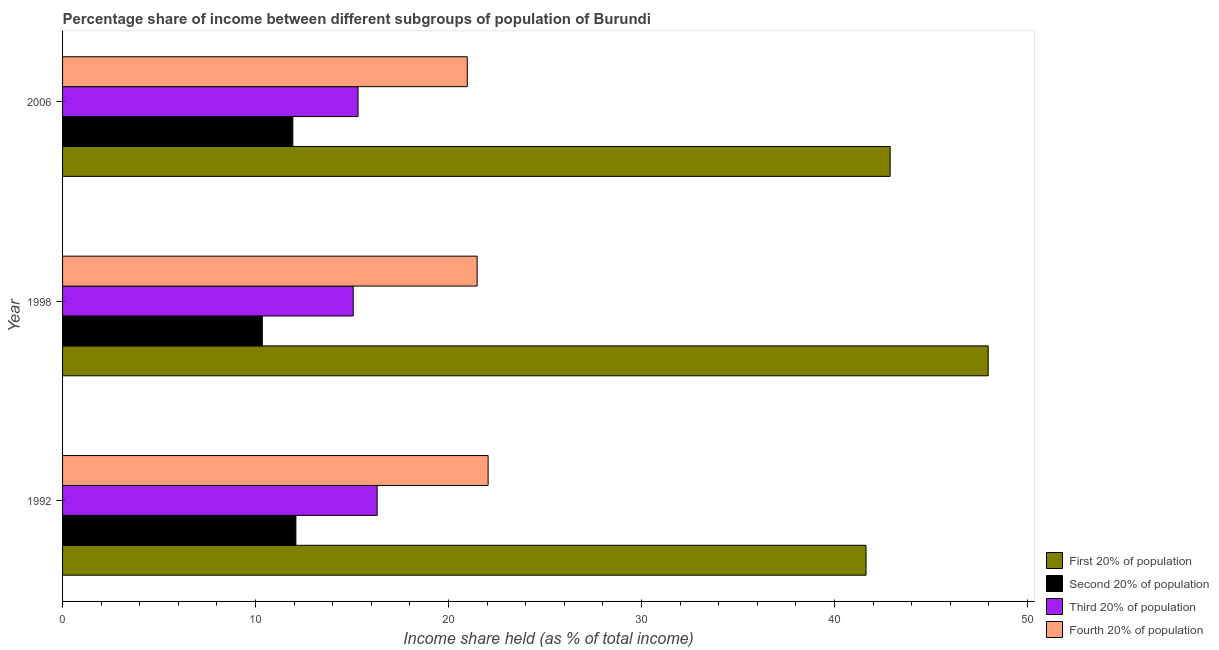How many bars are there on the 3rd tick from the top?
Your answer should be compact. 4. What is the label of the 1st group of bars from the top?
Your answer should be compact. 2006. In how many cases, is the number of bars for a given year not equal to the number of legend labels?
Your response must be concise. 0. What is the share of the income held by fourth 20% of the population in 2006?
Give a very brief answer. 20.97. Across all years, what is the maximum share of the income held by fourth 20% of the population?
Provide a succinct answer. 22.05. Across all years, what is the minimum share of the income held by third 20% of the population?
Your answer should be compact. 15.06. What is the total share of the income held by second 20% of the population in the graph?
Give a very brief answer. 34.37. What is the difference between the share of the income held by first 20% of the population in 1998 and that in 2006?
Make the answer very short. 5.08. What is the difference between the share of the income held by first 20% of the population in 1998 and the share of the income held by second 20% of the population in 2006?
Keep it short and to the point. 36.03. What is the average share of the income held by third 20% of the population per year?
Give a very brief answer. 15.56. In the year 2006, what is the difference between the share of the income held by second 20% of the population and share of the income held by third 20% of the population?
Offer a terse response. -3.38. In how many years, is the share of the income held by third 20% of the population greater than 30 %?
Make the answer very short. 0. What is the ratio of the share of the income held by first 20% of the population in 1998 to that in 2006?
Keep it short and to the point. 1.12. Is the share of the income held by third 20% of the population in 1998 less than that in 2006?
Your answer should be compact. Yes. What is the difference between the highest and the second highest share of the income held by second 20% of the population?
Provide a succinct answer. 0.16. What is the difference between the highest and the lowest share of the income held by fourth 20% of the population?
Make the answer very short. 1.08. In how many years, is the share of the income held by fourth 20% of the population greater than the average share of the income held by fourth 20% of the population taken over all years?
Offer a very short reply. 1. Is the sum of the share of the income held by third 20% of the population in 1992 and 1998 greater than the maximum share of the income held by second 20% of the population across all years?
Offer a terse response. Yes. What does the 3rd bar from the top in 1992 represents?
Your answer should be very brief. Second 20% of population. What does the 3rd bar from the bottom in 1998 represents?
Offer a terse response. Third 20% of population. Is it the case that in every year, the sum of the share of the income held by first 20% of the population and share of the income held by second 20% of the population is greater than the share of the income held by third 20% of the population?
Provide a succinct answer. Yes. How many bars are there?
Provide a succinct answer. 12. How many years are there in the graph?
Give a very brief answer. 3. Are the values on the major ticks of X-axis written in scientific E-notation?
Provide a succinct answer. No. How many legend labels are there?
Offer a terse response. 4. What is the title of the graph?
Ensure brevity in your answer.  Percentage share of income between different subgroups of population of Burundi. Does "UNRWA" appear as one of the legend labels in the graph?
Offer a very short reply. No. What is the label or title of the X-axis?
Give a very brief answer. Income share held (as % of total income). What is the label or title of the Y-axis?
Offer a terse response. Year. What is the Income share held (as % of total income) of First 20% of population in 1992?
Your answer should be compact. 41.63. What is the Income share held (as % of total income) of Second 20% of population in 1992?
Your answer should be very brief. 12.09. What is the Income share held (as % of total income) in Third 20% of population in 1992?
Provide a succinct answer. 16.3. What is the Income share held (as % of total income) of Fourth 20% of population in 1992?
Your response must be concise. 22.05. What is the Income share held (as % of total income) in First 20% of population in 1998?
Offer a very short reply. 47.96. What is the Income share held (as % of total income) in Second 20% of population in 1998?
Give a very brief answer. 10.35. What is the Income share held (as % of total income) of Third 20% of population in 1998?
Give a very brief answer. 15.06. What is the Income share held (as % of total income) of Fourth 20% of population in 1998?
Offer a terse response. 21.48. What is the Income share held (as % of total income) of First 20% of population in 2006?
Your answer should be very brief. 42.88. What is the Income share held (as % of total income) in Second 20% of population in 2006?
Your answer should be very brief. 11.93. What is the Income share held (as % of total income) of Third 20% of population in 2006?
Your response must be concise. 15.31. What is the Income share held (as % of total income) in Fourth 20% of population in 2006?
Keep it short and to the point. 20.97. Across all years, what is the maximum Income share held (as % of total income) of First 20% of population?
Offer a very short reply. 47.96. Across all years, what is the maximum Income share held (as % of total income) in Second 20% of population?
Keep it short and to the point. 12.09. Across all years, what is the maximum Income share held (as % of total income) in Fourth 20% of population?
Make the answer very short. 22.05. Across all years, what is the minimum Income share held (as % of total income) in First 20% of population?
Give a very brief answer. 41.63. Across all years, what is the minimum Income share held (as % of total income) in Second 20% of population?
Give a very brief answer. 10.35. Across all years, what is the minimum Income share held (as % of total income) of Third 20% of population?
Keep it short and to the point. 15.06. Across all years, what is the minimum Income share held (as % of total income) in Fourth 20% of population?
Provide a succinct answer. 20.97. What is the total Income share held (as % of total income) in First 20% of population in the graph?
Your answer should be compact. 132.47. What is the total Income share held (as % of total income) in Second 20% of population in the graph?
Your response must be concise. 34.37. What is the total Income share held (as % of total income) in Third 20% of population in the graph?
Ensure brevity in your answer.  46.67. What is the total Income share held (as % of total income) in Fourth 20% of population in the graph?
Keep it short and to the point. 64.5. What is the difference between the Income share held (as % of total income) in First 20% of population in 1992 and that in 1998?
Offer a terse response. -6.33. What is the difference between the Income share held (as % of total income) of Second 20% of population in 1992 and that in 1998?
Ensure brevity in your answer.  1.74. What is the difference between the Income share held (as % of total income) in Third 20% of population in 1992 and that in 1998?
Your response must be concise. 1.24. What is the difference between the Income share held (as % of total income) of Fourth 20% of population in 1992 and that in 1998?
Keep it short and to the point. 0.57. What is the difference between the Income share held (as % of total income) of First 20% of population in 1992 and that in 2006?
Offer a terse response. -1.25. What is the difference between the Income share held (as % of total income) in Second 20% of population in 1992 and that in 2006?
Offer a terse response. 0.16. What is the difference between the Income share held (as % of total income) in Fourth 20% of population in 1992 and that in 2006?
Give a very brief answer. 1.08. What is the difference between the Income share held (as % of total income) of First 20% of population in 1998 and that in 2006?
Your answer should be very brief. 5.08. What is the difference between the Income share held (as % of total income) in Second 20% of population in 1998 and that in 2006?
Provide a succinct answer. -1.58. What is the difference between the Income share held (as % of total income) of Fourth 20% of population in 1998 and that in 2006?
Offer a very short reply. 0.51. What is the difference between the Income share held (as % of total income) in First 20% of population in 1992 and the Income share held (as % of total income) in Second 20% of population in 1998?
Offer a terse response. 31.28. What is the difference between the Income share held (as % of total income) of First 20% of population in 1992 and the Income share held (as % of total income) of Third 20% of population in 1998?
Your response must be concise. 26.57. What is the difference between the Income share held (as % of total income) in First 20% of population in 1992 and the Income share held (as % of total income) in Fourth 20% of population in 1998?
Your answer should be very brief. 20.15. What is the difference between the Income share held (as % of total income) of Second 20% of population in 1992 and the Income share held (as % of total income) of Third 20% of population in 1998?
Offer a terse response. -2.97. What is the difference between the Income share held (as % of total income) in Second 20% of population in 1992 and the Income share held (as % of total income) in Fourth 20% of population in 1998?
Make the answer very short. -9.39. What is the difference between the Income share held (as % of total income) in Third 20% of population in 1992 and the Income share held (as % of total income) in Fourth 20% of population in 1998?
Make the answer very short. -5.18. What is the difference between the Income share held (as % of total income) of First 20% of population in 1992 and the Income share held (as % of total income) of Second 20% of population in 2006?
Your response must be concise. 29.7. What is the difference between the Income share held (as % of total income) of First 20% of population in 1992 and the Income share held (as % of total income) of Third 20% of population in 2006?
Your response must be concise. 26.32. What is the difference between the Income share held (as % of total income) in First 20% of population in 1992 and the Income share held (as % of total income) in Fourth 20% of population in 2006?
Provide a succinct answer. 20.66. What is the difference between the Income share held (as % of total income) in Second 20% of population in 1992 and the Income share held (as % of total income) in Third 20% of population in 2006?
Keep it short and to the point. -3.22. What is the difference between the Income share held (as % of total income) of Second 20% of population in 1992 and the Income share held (as % of total income) of Fourth 20% of population in 2006?
Give a very brief answer. -8.88. What is the difference between the Income share held (as % of total income) of Third 20% of population in 1992 and the Income share held (as % of total income) of Fourth 20% of population in 2006?
Provide a short and direct response. -4.67. What is the difference between the Income share held (as % of total income) of First 20% of population in 1998 and the Income share held (as % of total income) of Second 20% of population in 2006?
Your answer should be compact. 36.03. What is the difference between the Income share held (as % of total income) in First 20% of population in 1998 and the Income share held (as % of total income) in Third 20% of population in 2006?
Give a very brief answer. 32.65. What is the difference between the Income share held (as % of total income) of First 20% of population in 1998 and the Income share held (as % of total income) of Fourth 20% of population in 2006?
Ensure brevity in your answer.  26.99. What is the difference between the Income share held (as % of total income) in Second 20% of population in 1998 and the Income share held (as % of total income) in Third 20% of population in 2006?
Keep it short and to the point. -4.96. What is the difference between the Income share held (as % of total income) of Second 20% of population in 1998 and the Income share held (as % of total income) of Fourth 20% of population in 2006?
Provide a short and direct response. -10.62. What is the difference between the Income share held (as % of total income) of Third 20% of population in 1998 and the Income share held (as % of total income) of Fourth 20% of population in 2006?
Keep it short and to the point. -5.91. What is the average Income share held (as % of total income) of First 20% of population per year?
Ensure brevity in your answer.  44.16. What is the average Income share held (as % of total income) of Second 20% of population per year?
Your answer should be compact. 11.46. What is the average Income share held (as % of total income) of Third 20% of population per year?
Your answer should be compact. 15.56. In the year 1992, what is the difference between the Income share held (as % of total income) in First 20% of population and Income share held (as % of total income) in Second 20% of population?
Keep it short and to the point. 29.54. In the year 1992, what is the difference between the Income share held (as % of total income) in First 20% of population and Income share held (as % of total income) in Third 20% of population?
Keep it short and to the point. 25.33. In the year 1992, what is the difference between the Income share held (as % of total income) of First 20% of population and Income share held (as % of total income) of Fourth 20% of population?
Provide a short and direct response. 19.58. In the year 1992, what is the difference between the Income share held (as % of total income) of Second 20% of population and Income share held (as % of total income) of Third 20% of population?
Your answer should be compact. -4.21. In the year 1992, what is the difference between the Income share held (as % of total income) in Second 20% of population and Income share held (as % of total income) in Fourth 20% of population?
Provide a short and direct response. -9.96. In the year 1992, what is the difference between the Income share held (as % of total income) of Third 20% of population and Income share held (as % of total income) of Fourth 20% of population?
Make the answer very short. -5.75. In the year 1998, what is the difference between the Income share held (as % of total income) in First 20% of population and Income share held (as % of total income) in Second 20% of population?
Ensure brevity in your answer.  37.61. In the year 1998, what is the difference between the Income share held (as % of total income) in First 20% of population and Income share held (as % of total income) in Third 20% of population?
Your response must be concise. 32.9. In the year 1998, what is the difference between the Income share held (as % of total income) in First 20% of population and Income share held (as % of total income) in Fourth 20% of population?
Your answer should be very brief. 26.48. In the year 1998, what is the difference between the Income share held (as % of total income) of Second 20% of population and Income share held (as % of total income) of Third 20% of population?
Your answer should be compact. -4.71. In the year 1998, what is the difference between the Income share held (as % of total income) in Second 20% of population and Income share held (as % of total income) in Fourth 20% of population?
Ensure brevity in your answer.  -11.13. In the year 1998, what is the difference between the Income share held (as % of total income) in Third 20% of population and Income share held (as % of total income) in Fourth 20% of population?
Provide a short and direct response. -6.42. In the year 2006, what is the difference between the Income share held (as % of total income) of First 20% of population and Income share held (as % of total income) of Second 20% of population?
Offer a terse response. 30.95. In the year 2006, what is the difference between the Income share held (as % of total income) of First 20% of population and Income share held (as % of total income) of Third 20% of population?
Make the answer very short. 27.57. In the year 2006, what is the difference between the Income share held (as % of total income) in First 20% of population and Income share held (as % of total income) in Fourth 20% of population?
Make the answer very short. 21.91. In the year 2006, what is the difference between the Income share held (as % of total income) in Second 20% of population and Income share held (as % of total income) in Third 20% of population?
Keep it short and to the point. -3.38. In the year 2006, what is the difference between the Income share held (as % of total income) of Second 20% of population and Income share held (as % of total income) of Fourth 20% of population?
Give a very brief answer. -9.04. In the year 2006, what is the difference between the Income share held (as % of total income) in Third 20% of population and Income share held (as % of total income) in Fourth 20% of population?
Your answer should be very brief. -5.66. What is the ratio of the Income share held (as % of total income) of First 20% of population in 1992 to that in 1998?
Ensure brevity in your answer.  0.87. What is the ratio of the Income share held (as % of total income) of Second 20% of population in 1992 to that in 1998?
Your answer should be very brief. 1.17. What is the ratio of the Income share held (as % of total income) of Third 20% of population in 1992 to that in 1998?
Keep it short and to the point. 1.08. What is the ratio of the Income share held (as % of total income) in Fourth 20% of population in 1992 to that in 1998?
Give a very brief answer. 1.03. What is the ratio of the Income share held (as % of total income) of First 20% of population in 1992 to that in 2006?
Offer a very short reply. 0.97. What is the ratio of the Income share held (as % of total income) of Second 20% of population in 1992 to that in 2006?
Your answer should be compact. 1.01. What is the ratio of the Income share held (as % of total income) of Third 20% of population in 1992 to that in 2006?
Offer a terse response. 1.06. What is the ratio of the Income share held (as % of total income) of Fourth 20% of population in 1992 to that in 2006?
Provide a short and direct response. 1.05. What is the ratio of the Income share held (as % of total income) of First 20% of population in 1998 to that in 2006?
Your answer should be compact. 1.12. What is the ratio of the Income share held (as % of total income) in Second 20% of population in 1998 to that in 2006?
Provide a succinct answer. 0.87. What is the ratio of the Income share held (as % of total income) of Third 20% of population in 1998 to that in 2006?
Keep it short and to the point. 0.98. What is the ratio of the Income share held (as % of total income) of Fourth 20% of population in 1998 to that in 2006?
Keep it short and to the point. 1.02. What is the difference between the highest and the second highest Income share held (as % of total income) in First 20% of population?
Provide a succinct answer. 5.08. What is the difference between the highest and the second highest Income share held (as % of total income) of Second 20% of population?
Offer a very short reply. 0.16. What is the difference between the highest and the second highest Income share held (as % of total income) of Third 20% of population?
Offer a very short reply. 0.99. What is the difference between the highest and the second highest Income share held (as % of total income) in Fourth 20% of population?
Your response must be concise. 0.57. What is the difference between the highest and the lowest Income share held (as % of total income) of First 20% of population?
Keep it short and to the point. 6.33. What is the difference between the highest and the lowest Income share held (as % of total income) in Second 20% of population?
Provide a succinct answer. 1.74. What is the difference between the highest and the lowest Income share held (as % of total income) in Third 20% of population?
Your answer should be very brief. 1.24. 